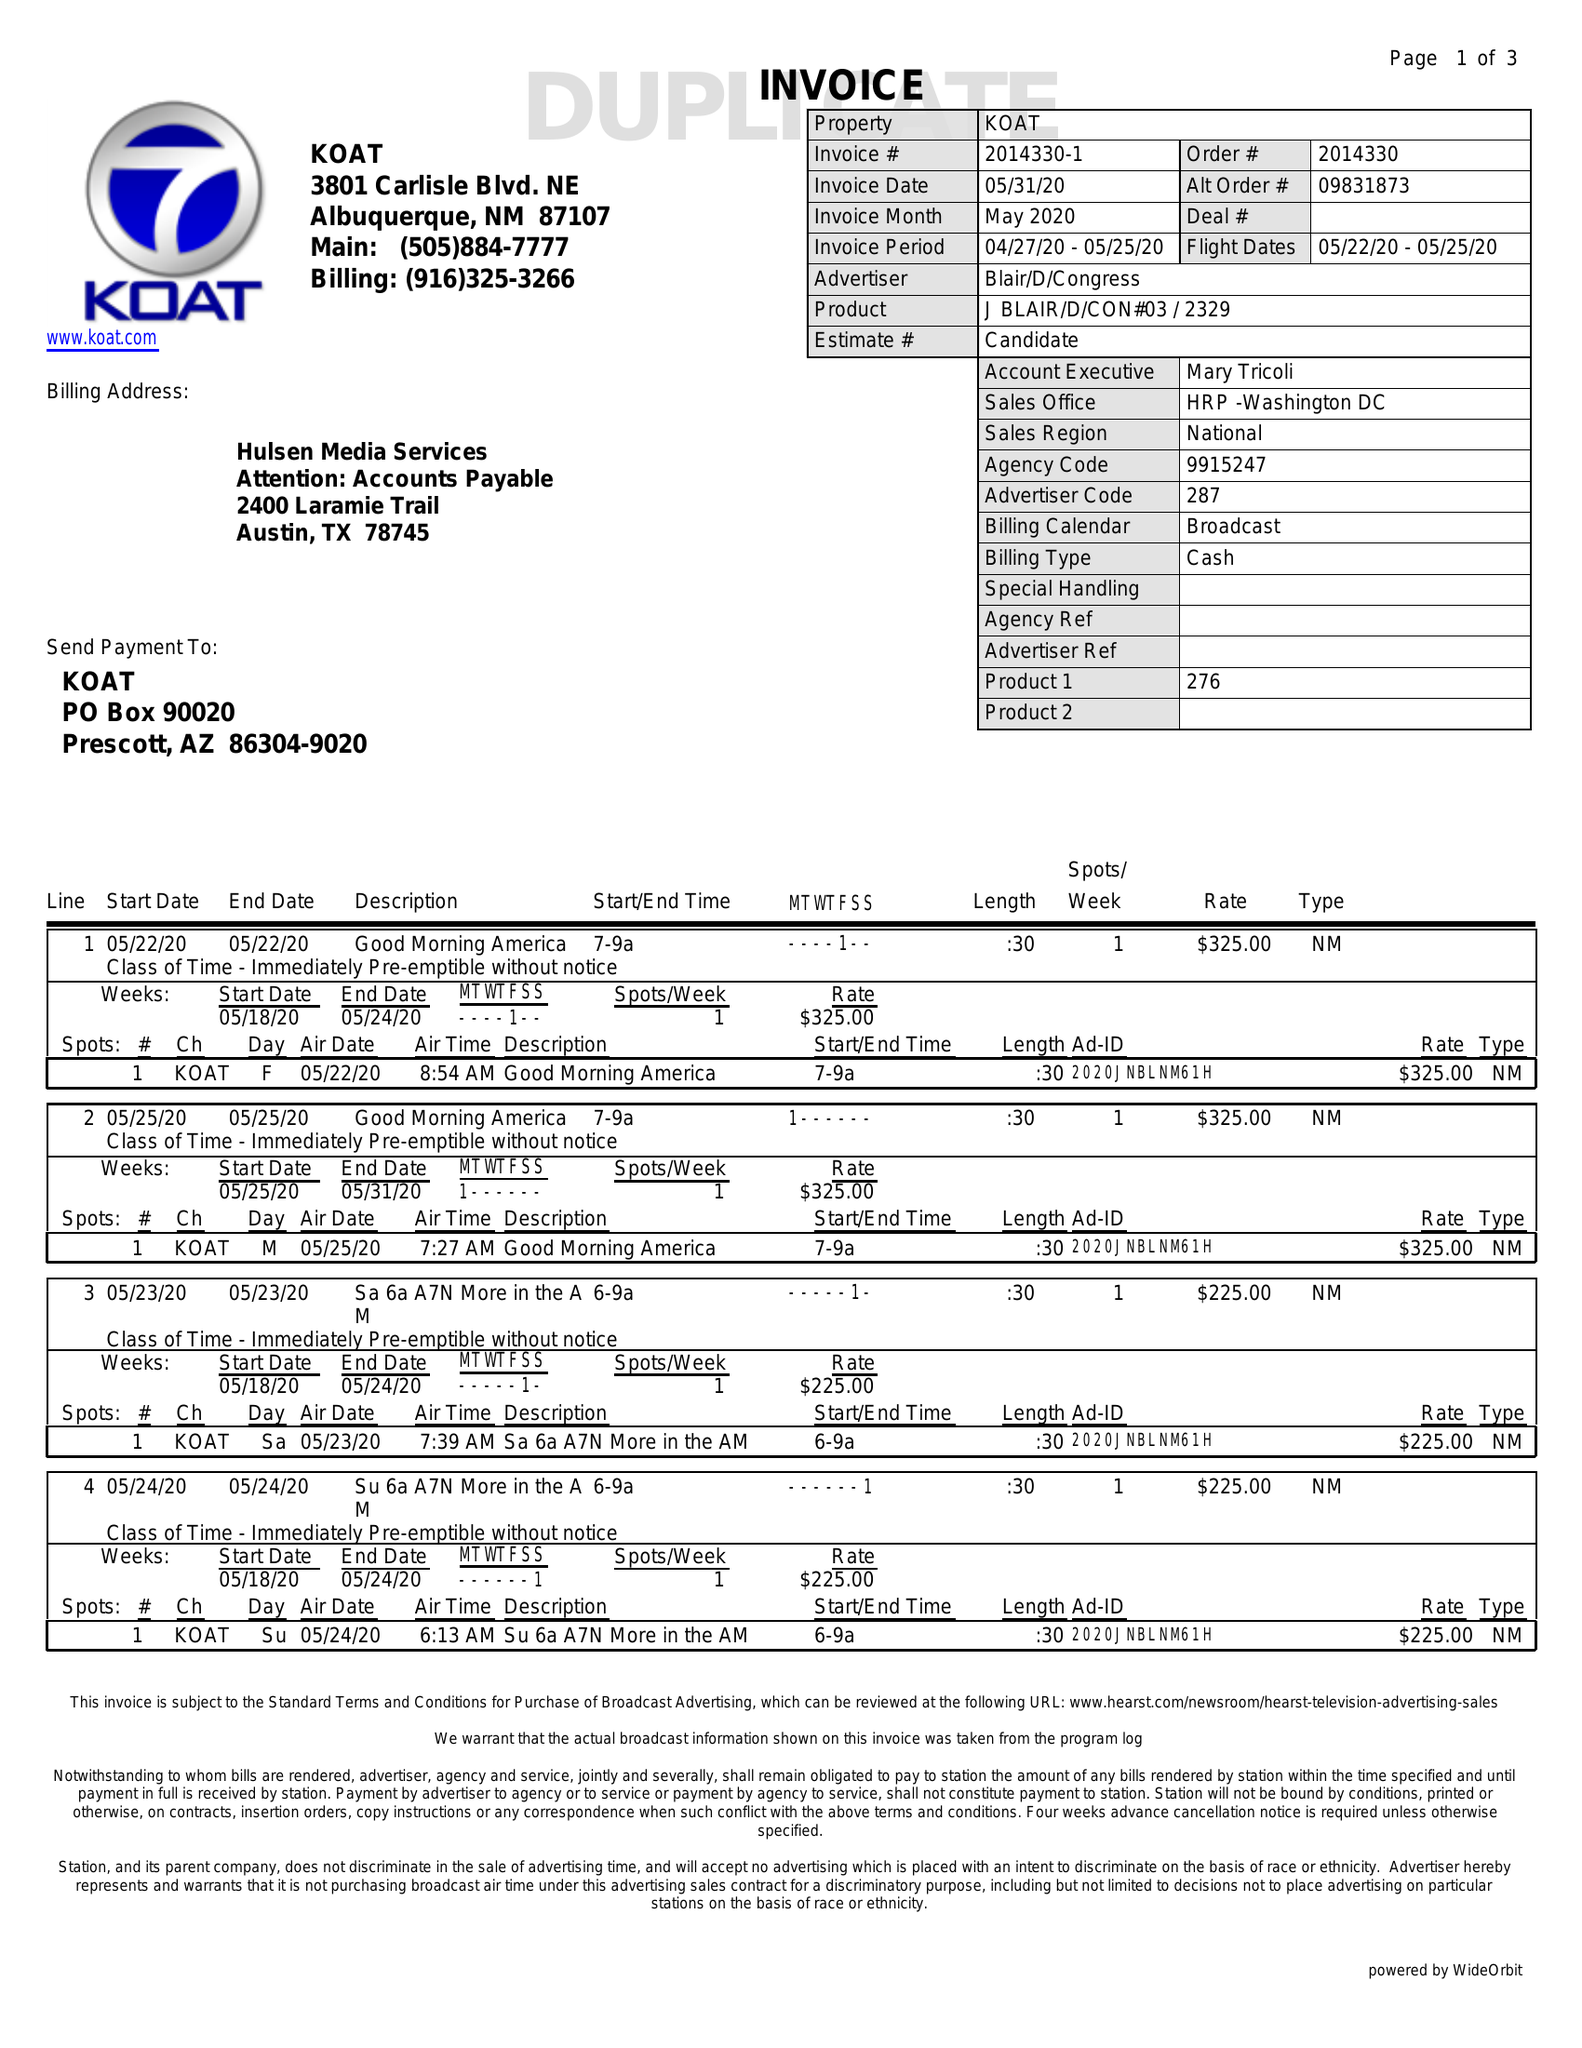What is the value for the flight_to?
Answer the question using a single word or phrase. 05/25/20 